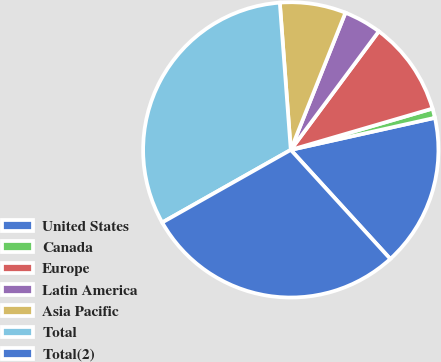Convert chart to OTSL. <chart><loc_0><loc_0><loc_500><loc_500><pie_chart><fcel>United States<fcel>Canada<fcel>Europe<fcel>Latin America<fcel>Asia Pacific<fcel>Total<fcel>Total(2)<nl><fcel>16.71%<fcel>1.03%<fcel>10.32%<fcel>4.13%<fcel>7.22%<fcel>32.0%<fcel>28.59%<nl></chart> 